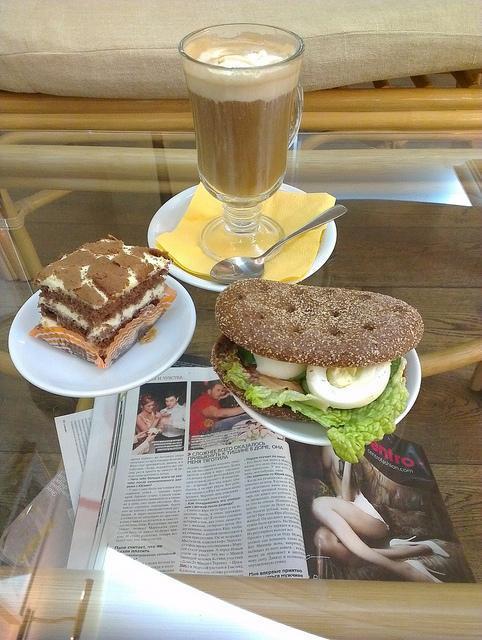How many couches are there?
Give a very brief answer. 1. How many doors does the bus have?
Give a very brief answer. 0. 